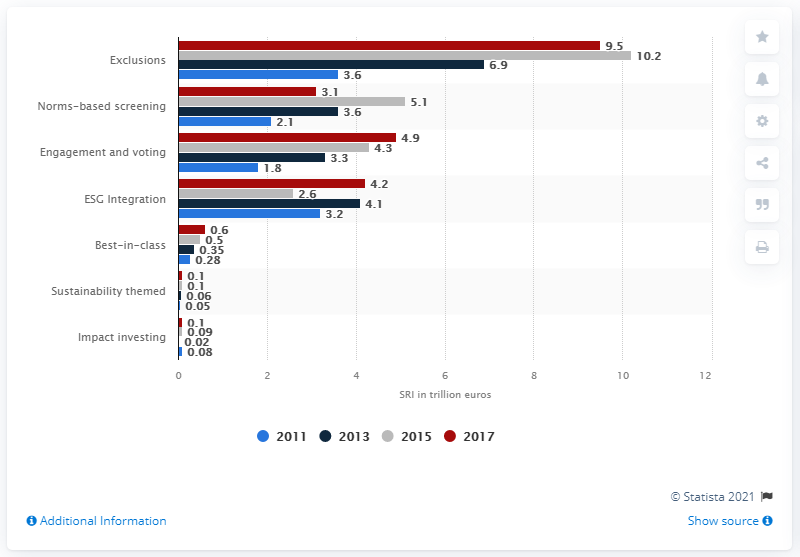Point out several critical features in this image. The investment level of exclusion-led investment strategies in 2011 was 3.6. In 2017, the application of the exclusion strategy resulted in an investment of $9.5 million. 